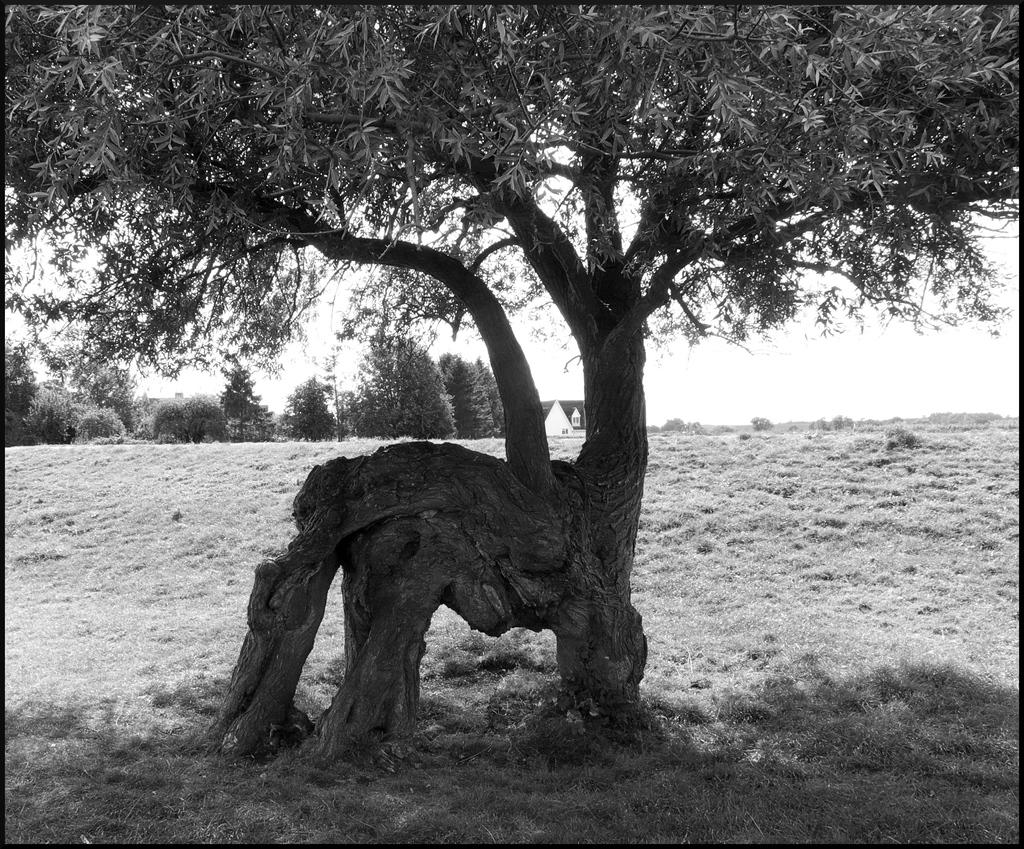What is the main subject in the picture? There is a tree in the picture. What can be observed about the tree? The tree has leaves. What else can be seen in the background of the picture? There are other trees in the background of the picture. How would you describe the sky in the image? The sky is clear in the image. Where is the key to the boat in the image? There is no boat or key present in the image; it only features a tree and other trees in the background. 